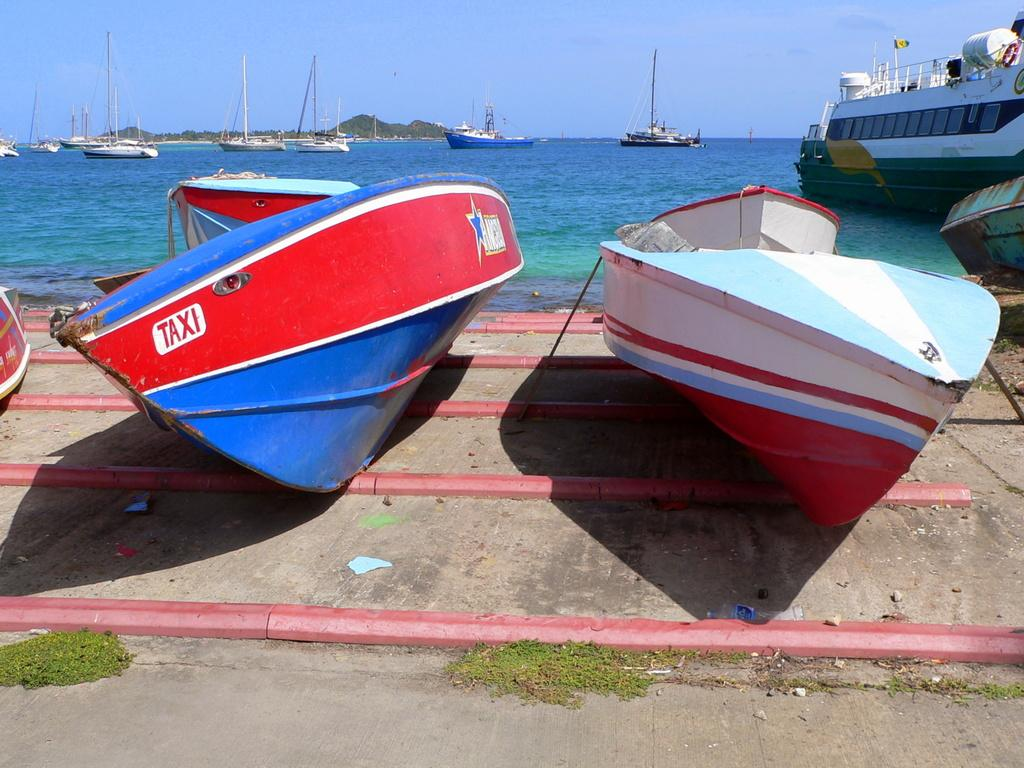What type of vehicles are present in the image? There are boats in the image. Where are the boats located in the image? Some boats are on the ground, while others are on the water. What can be seen in the background of the image? There are mountains and the sky visible in the background of the image. How many people are in the crowd watching the ring in the image? There is no crowd, ring, or any related activity present in the image; it features boats on the ground and water, with mountains and the sky in the background. 